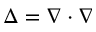<formula> <loc_0><loc_0><loc_500><loc_500>\Delta = \nabla \cdot \nabla</formula> 